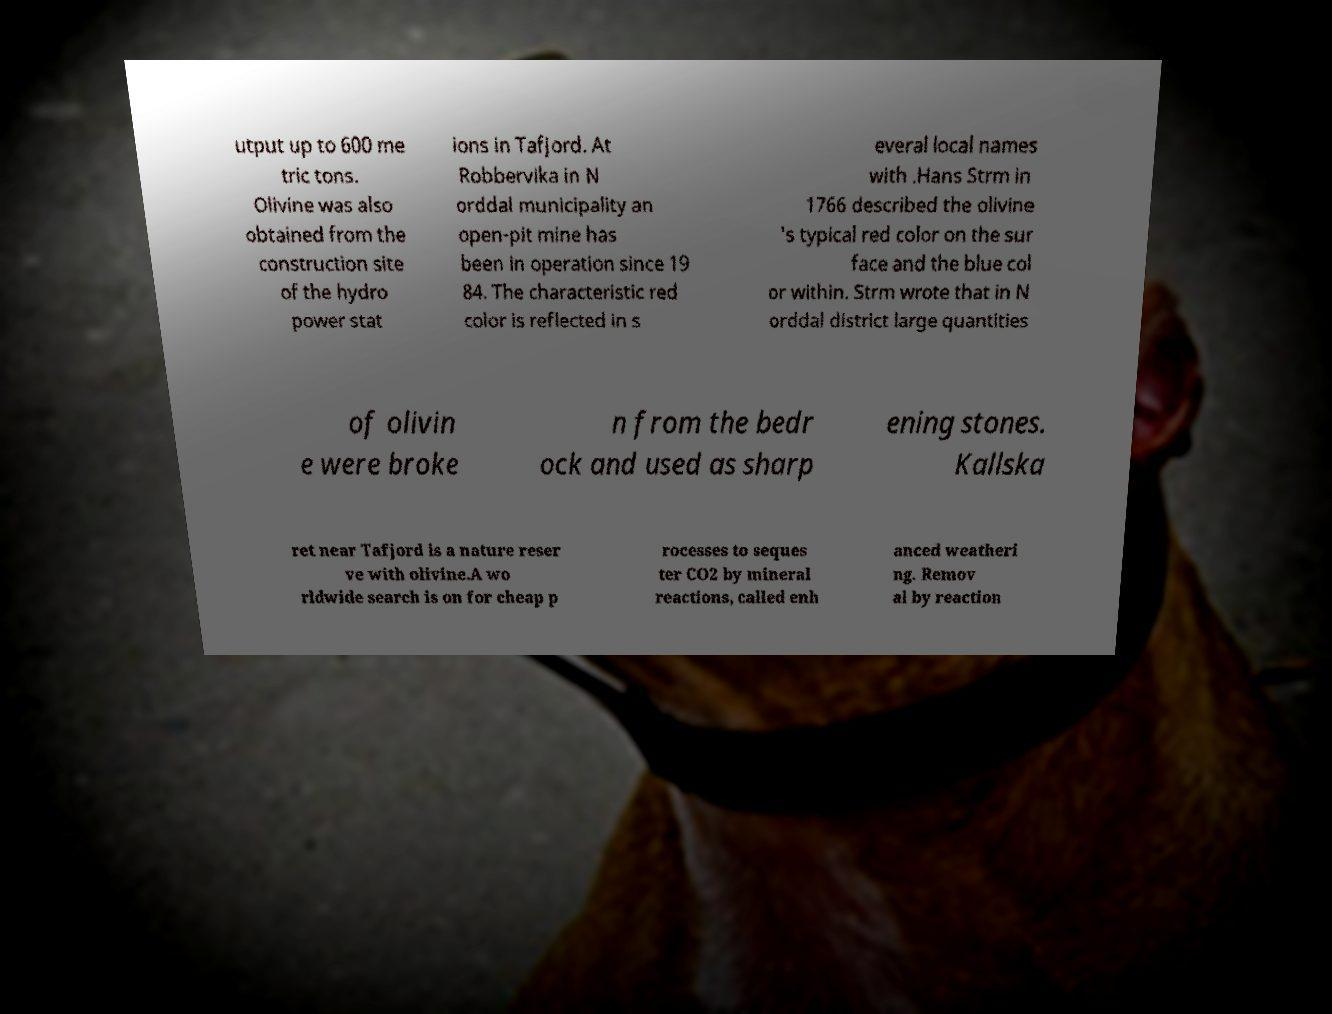I need the written content from this picture converted into text. Can you do that? utput up to 600 me tric tons. Olivine was also obtained from the construction site of the hydro power stat ions in Tafjord. At Robbervika in N orddal municipality an open-pit mine has been in operation since 19 84. The characteristic red color is reflected in s everal local names with .Hans Strm in 1766 described the olivine 's typical red color on the sur face and the blue col or within. Strm wrote that in N orddal district large quantities of olivin e were broke n from the bedr ock and used as sharp ening stones. Kallska ret near Tafjord is a nature reser ve with olivine.A wo rldwide search is on for cheap p rocesses to seques ter CO2 by mineral reactions, called enh anced weatheri ng. Remov al by reaction 